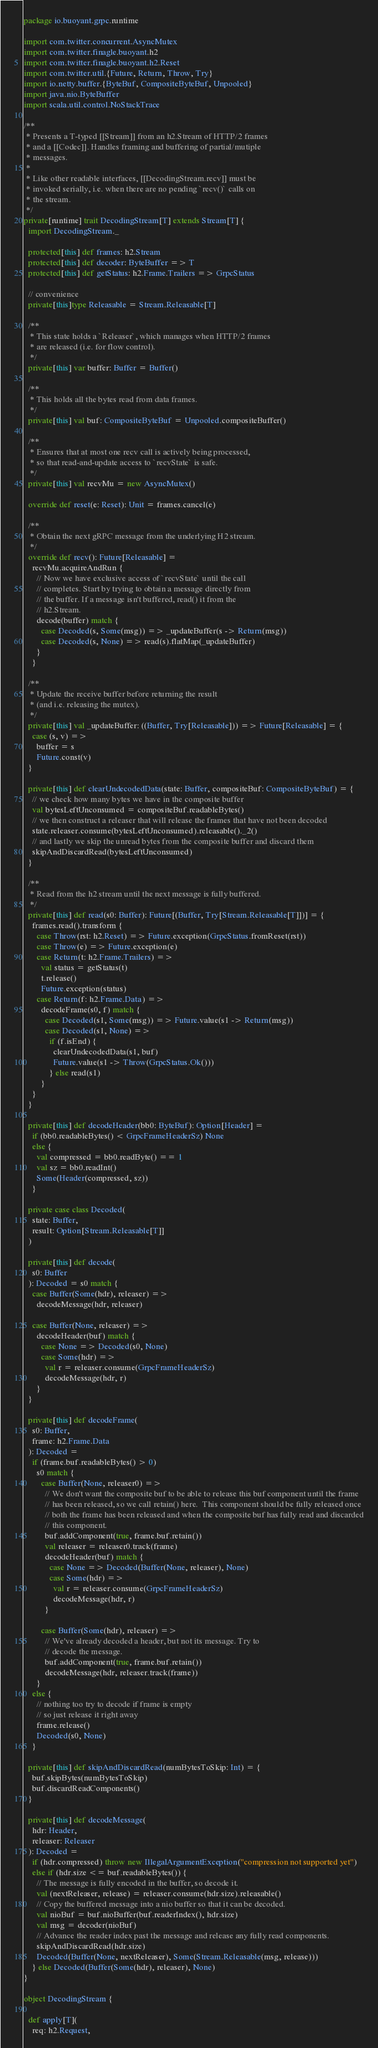<code> <loc_0><loc_0><loc_500><loc_500><_Scala_>package io.buoyant.grpc.runtime

import com.twitter.concurrent.AsyncMutex
import com.twitter.finagle.buoyant.h2
import com.twitter.finagle.buoyant.h2.Reset
import com.twitter.util.{Future, Return, Throw, Try}
import io.netty.buffer.{ByteBuf, CompositeByteBuf, Unpooled}
import java.nio.ByteBuffer
import scala.util.control.NoStackTrace

/**
 * Presents a T-typed [[Stream]] from an h2.Stream of HTTP/2 frames
 * and a [[Codec]]. Handles framing and buffering of partial/mutiple
 * messages.
 *
 * Like other readable interfaces, [[DecodingStream.recv]] must be
 * invoked serially, i.e. when there are no pending `recv()` calls on
 * the stream.
 */
private[runtime] trait DecodingStream[T] extends Stream[T] {
  import DecodingStream._

  protected[this] def frames: h2.Stream
  protected[this] def decoder: ByteBuffer => T
  protected[this] def getStatus: h2.Frame.Trailers => GrpcStatus

  // convenience
  private[this]type Releasable = Stream.Releasable[T]

  /**
   * This state holds a `Releaser`, which manages when HTTP/2 frames
   * are released (i.e. for flow control).
   */
  private[this] var buffer: Buffer = Buffer()

  /**
   * This holds all the bytes read from data frames.
   */
  private[this] val buf: CompositeByteBuf = Unpooled.compositeBuffer()

  /**
   * Ensures that at most one recv call is actively being processed,
   * so that read-and-update access to `recvState` is safe.
   */
  private[this] val recvMu = new AsyncMutex()

  override def reset(e: Reset): Unit = frames.cancel(e)

  /**
   * Obtain the next gRPC message from the underlying H2 stream.
   */
  override def recv(): Future[Releasable] =
    recvMu.acquireAndRun {
      // Now we have exclusive access of `recvState` until the call
      // completes. Start by trying to obtain a message directly from
      // the buffer. If a message isn't buffered, read() it from the
      // h2.Stream.
      decode(buffer) match {
        case Decoded(s, Some(msg)) => _updateBuffer(s -> Return(msg))
        case Decoded(s, None) => read(s).flatMap(_updateBuffer)
      }
    }

  /**
   * Update the receive buffer before returning the result
   * (and i.e. releasing the mutex).
   */
  private[this] val _updateBuffer: ((Buffer, Try[Releasable])) => Future[Releasable] = {
    case (s, v) =>
      buffer = s
      Future.const(v)
  }

  private[this] def clearUndecodedData(state: Buffer, compositeBuf: CompositeByteBuf) = {
    // we check how many bytes we have in the composite buffer
    val bytesLeftUnconsumed = compositeBuf.readableBytes()
    // we then construct a releaser that will release the frames that have not been decoded
    state.releaser.consume(bytesLeftUnconsumed).releasable()._2()
    // and lastly we skip the unread bytes from the composite buffer and discard them
    skipAndDiscardRead(bytesLeftUnconsumed)
  }

  /**
   * Read from the h2 stream until the next message is fully buffered.
   */
  private[this] def read(s0: Buffer): Future[(Buffer, Try[Stream.Releasable[T]])] = {
    frames.read().transform {
      case Throw(rst: h2.Reset) => Future.exception(GrpcStatus.fromReset(rst))
      case Throw(e) => Future.exception(e)
      case Return(t: h2.Frame.Trailers) =>
        val status = getStatus(t)
        t.release()
        Future.exception(status)
      case Return(f: h2.Frame.Data) =>
        decodeFrame(s0, f) match {
          case Decoded(s1, Some(msg)) => Future.value(s1 -> Return(msg))
          case Decoded(s1, None) =>
            if (f.isEnd) {
              clearUndecodedData(s1, buf)
              Future.value(s1 -> Throw(GrpcStatus.Ok()))
            } else read(s1)
        }
    }
  }

  private[this] def decodeHeader(bb0: ByteBuf): Option[Header] =
    if (bb0.readableBytes() < GrpcFrameHeaderSz) None
    else {
      val compressed = bb0.readByte() == 1
      val sz = bb0.readInt()
      Some(Header(compressed, sz))
    }

  private case class Decoded(
    state: Buffer,
    result: Option[Stream.Releasable[T]]
  )

  private[this] def decode(
    s0: Buffer
  ): Decoded = s0 match {
    case Buffer(Some(hdr), releaser) =>
      decodeMessage(hdr, releaser)

    case Buffer(None, releaser) =>
      decodeHeader(buf) match {
        case None => Decoded(s0, None)
        case Some(hdr) =>
          val r = releaser.consume(GrpcFrameHeaderSz)
          decodeMessage(hdr, r)
      }
  }

  private[this] def decodeFrame(
    s0: Buffer,
    frame: h2.Frame.Data
  ): Decoded =
    if (frame.buf.readableBytes() > 0)
      s0 match {
        case Buffer(None, releaser0) =>
          // We don't want the composite buf to be able to release this buf component until the frame
          // has been released, so we call retain() here.  This component should be fully released once
          // both the frame has been released and when the composite buf has fully read and discarded
          // this component.
          buf.addComponent(true, frame.buf.retain())
          val releaser = releaser0.track(frame)
          decodeHeader(buf) match {
            case None => Decoded(Buffer(None, releaser), None)
            case Some(hdr) =>
              val r = releaser.consume(GrpcFrameHeaderSz)
              decodeMessage(hdr, r)
          }

        case Buffer(Some(hdr), releaser) =>
          // We've already decoded a header, but not its message. Try to
          // decode the message.
          buf.addComponent(true, frame.buf.retain())
          decodeMessage(hdr, releaser.track(frame))
      }
    else {
      // nothing too try to decode if frame is empty
      // so just release it right away
      frame.release()
      Decoded(s0, None)
    }

  private[this] def skipAndDiscardRead(numBytesToSkip: Int) = {
    buf.skipBytes(numBytesToSkip)
    buf.discardReadComponents()
  }

  private[this] def decodeMessage(
    hdr: Header,
    releaser: Releaser
  ): Decoded =
    if (hdr.compressed) throw new IllegalArgumentException("compression not supported yet")
    else if (hdr.size <= buf.readableBytes()) {
      // The message is fully encoded in the buffer, so decode it.
      val (nextReleaser, release) = releaser.consume(hdr.size).releasable()
      // Copy the buffered message into a nio buffer so that it can be decoded.
      val nioBuf = buf.nioBuffer(buf.readerIndex(), hdr.size)
      val msg = decoder(nioBuf)
      // Advance the reader index past the message and release any fully read components.
      skipAndDiscardRead(hdr.size)
      Decoded(Buffer(None, nextReleaser), Some(Stream.Releasable(msg, release)))
    } else Decoded(Buffer(Some(hdr), releaser), None)
}

object DecodingStream {

  def apply[T](
    req: h2.Request,</code> 